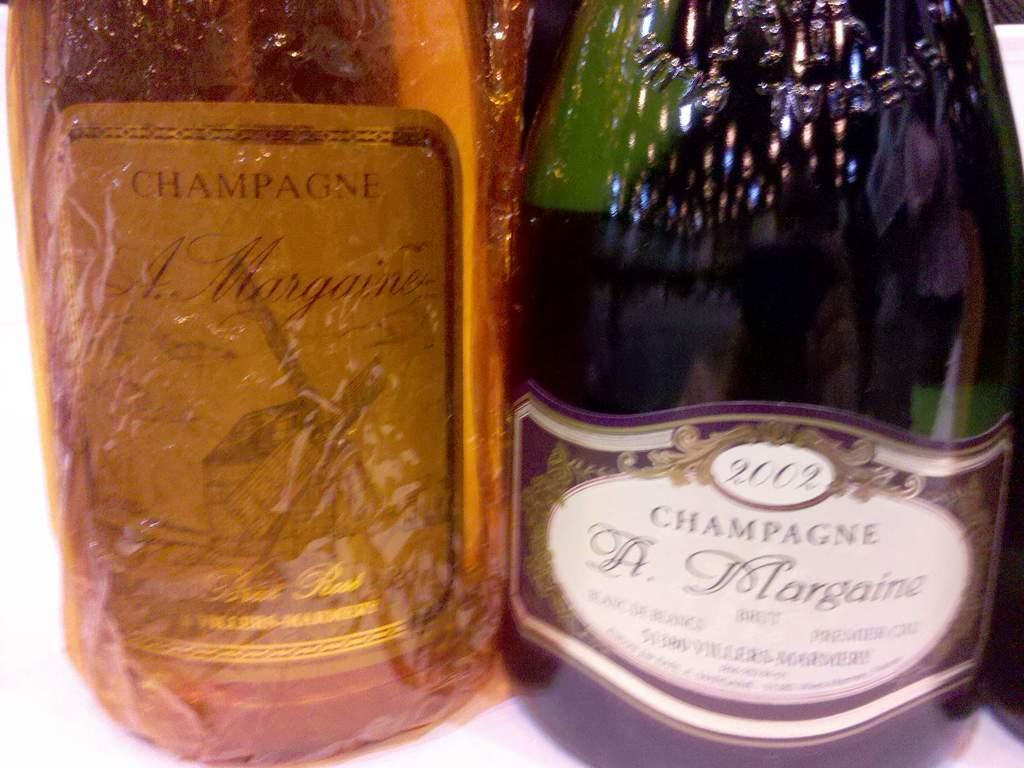<image>
Summarize the visual content of the image. yellow bottle of champagne with wrinkled label next to a green bottle of 2002 champagne 